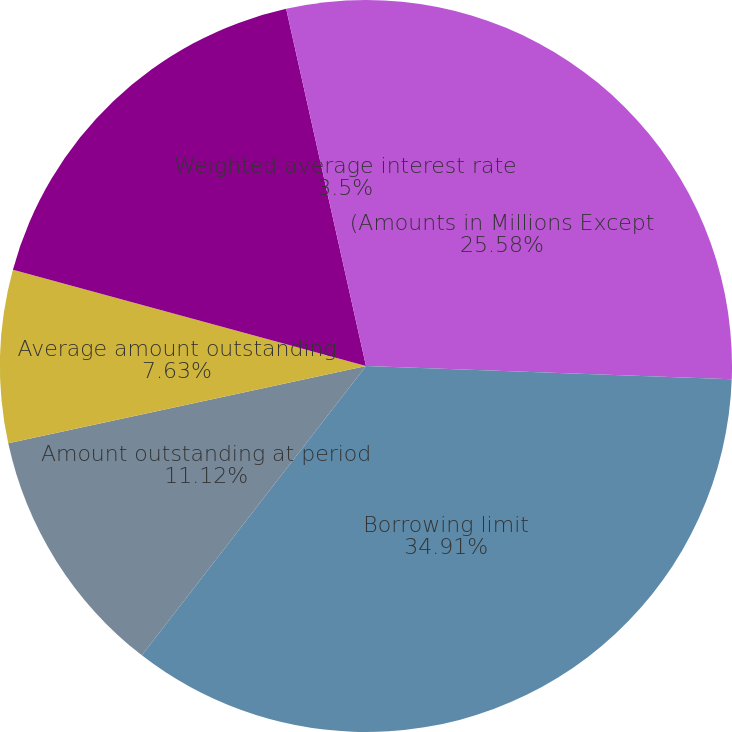Convert chart to OTSL. <chart><loc_0><loc_0><loc_500><loc_500><pie_chart><fcel>(Amounts in Millions Except<fcel>Borrowing limit<fcel>Amount outstanding at period<fcel>Average amount outstanding<fcel>Maximum amount outstanding<fcel>Weighted average interest rate<nl><fcel>25.58%<fcel>34.91%<fcel>11.12%<fcel>7.63%<fcel>17.26%<fcel>3.5%<nl></chart> 